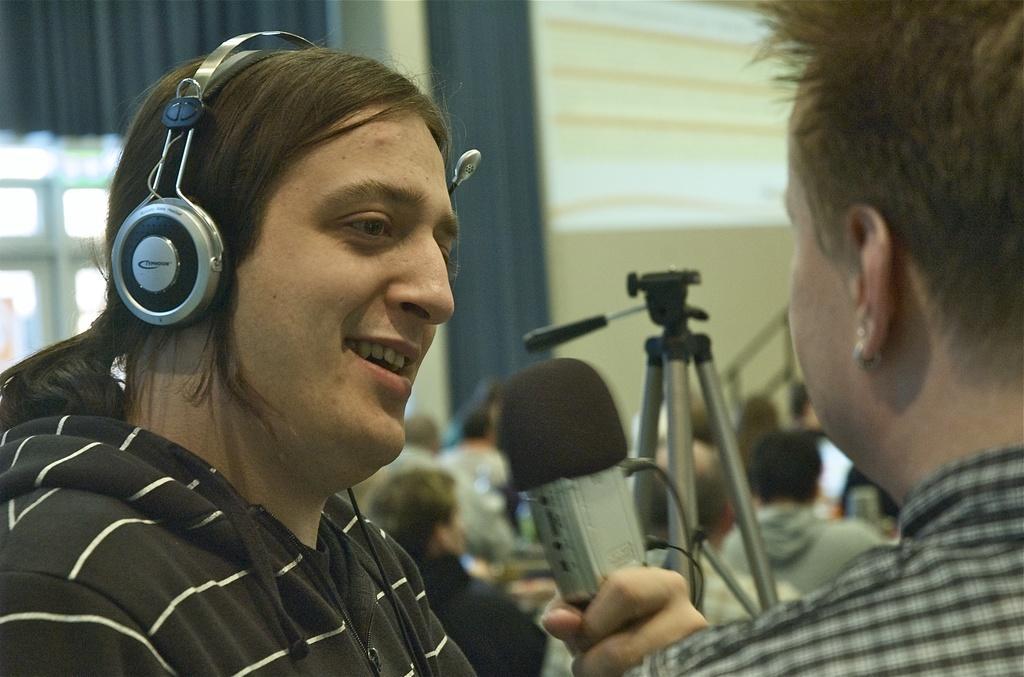Could you give a brief overview of what you see in this image? In this image I can see two people. One person is holding something. I can see stand,curtain,window,wall and few people. 